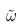<formula> <loc_0><loc_0><loc_500><loc_500>\tilde { \omega }</formula> 